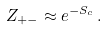<formula> <loc_0><loc_0><loc_500><loc_500>Z _ { + - } \approx e ^ { - S _ { c } } \, .</formula> 